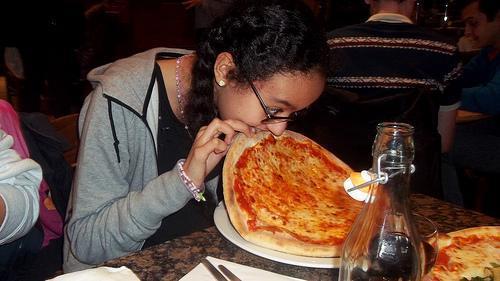How many pizza are there?
Give a very brief answer. 2. 